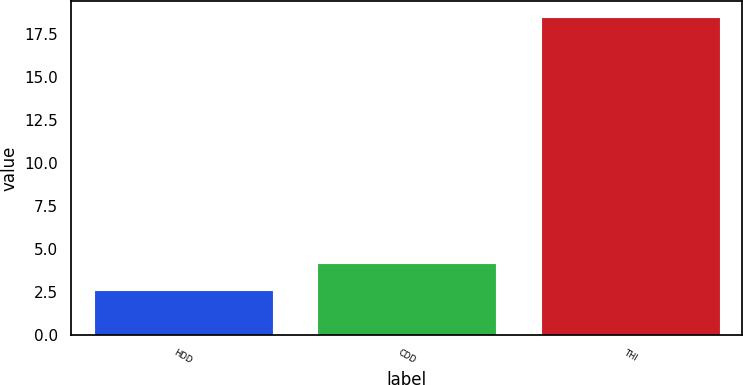Convert chart. <chart><loc_0><loc_0><loc_500><loc_500><bar_chart><fcel>HDD<fcel>CDD<fcel>THI<nl><fcel>2.6<fcel>4.19<fcel>18.5<nl></chart> 